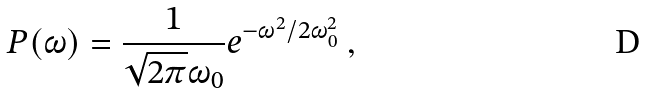Convert formula to latex. <formula><loc_0><loc_0><loc_500><loc_500>P ( \omega ) = \frac { 1 } { \sqrt { 2 \pi } \omega _ { 0 } } e ^ { - \omega ^ { 2 } / 2 \omega _ { 0 } ^ { 2 } } \ ,</formula> 